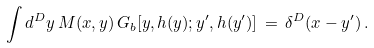<formula> <loc_0><loc_0><loc_500><loc_500>\int d ^ { D } y \, M ( { x } , { y } ) \, G _ { b } [ { y } , h ( { y } ) ; { y } ^ { \prime } , h ( { y } ^ { \prime } ) ] \, = \, \delta ^ { D } ( { x } - { y } ^ { \prime } ) \, .</formula> 